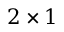<formula> <loc_0><loc_0><loc_500><loc_500>2 \times 1</formula> 